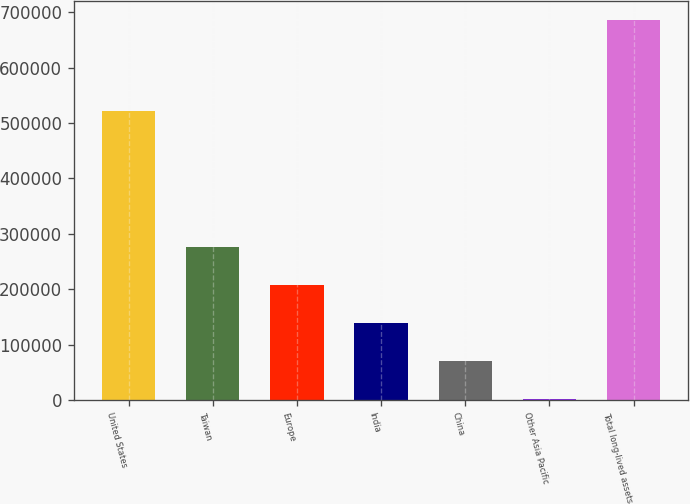Convert chart. <chart><loc_0><loc_0><loc_500><loc_500><bar_chart><fcel>United States<fcel>Taiwan<fcel>Europe<fcel>India<fcel>China<fcel>Other Asia Pacific<fcel>Total long-lived assets<nl><fcel>522461<fcel>275452<fcel>206862<fcel>138272<fcel>69682<fcel>1092<fcel>686992<nl></chart> 